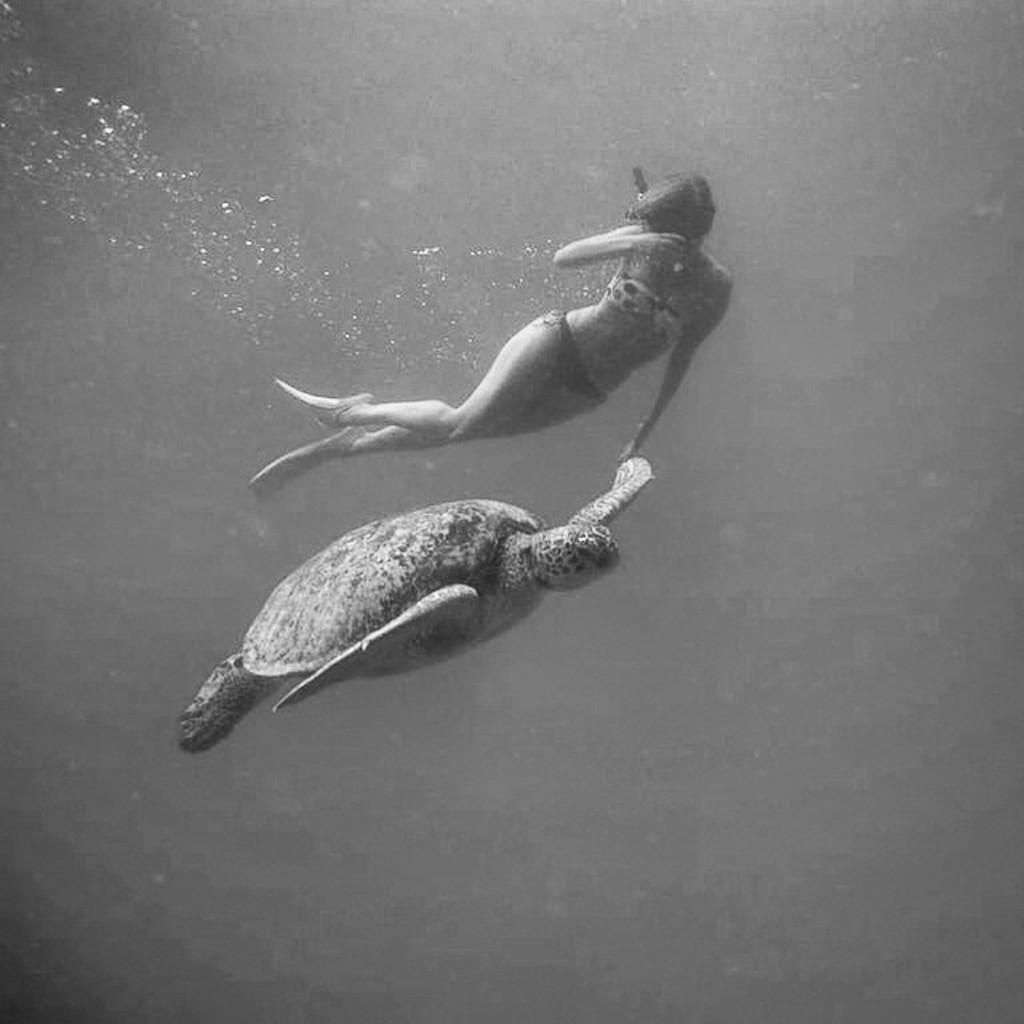What is the color scheme of the image? The image is black and white. Who or what can be seen in the image? There is a woman and a turtle in the image. Where are the woman and turtle located in the image? The woman and turtle are underwater in the image. What type of plantation can be seen in the image? There is no plantation present in the image; it features a woman and a turtle underwater. What shape is the square that the woman and turtle are swimming in? There is no square mentioned or visible in the image; it is underwater with no defined shape. 